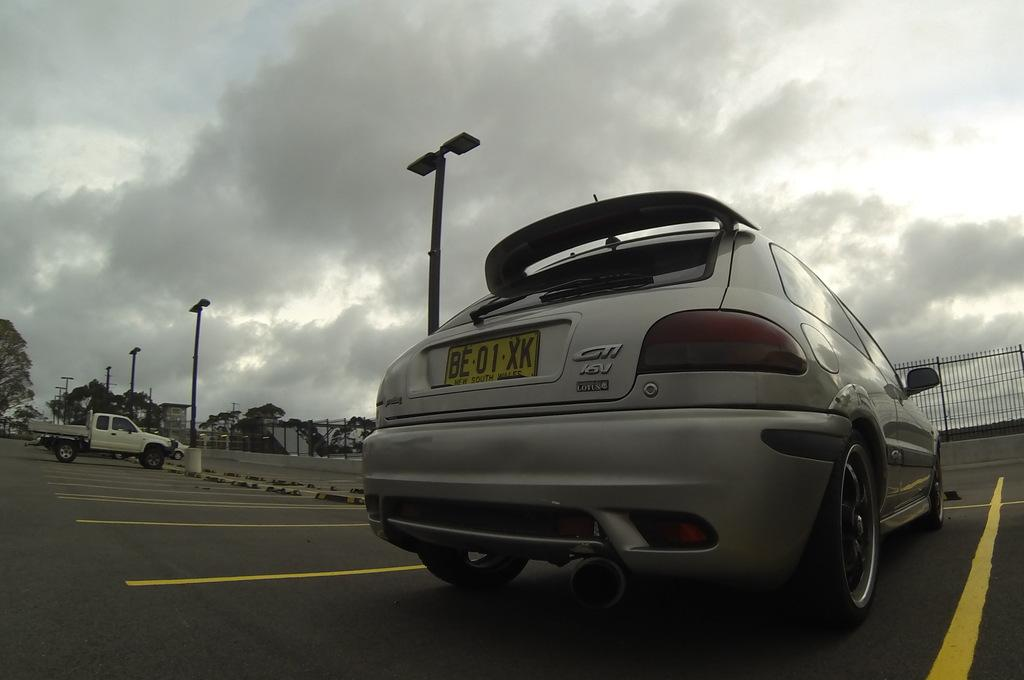What can be seen on the road in the image? There are vehicles on the road in the image. What type of markings are present on the road? The road has yellow lines. What structure is visible in the image? There is a light pole in the image. What type of natural elements are present in the image? Trees are present in the image. How would you describe the weather in the image? The sky is cloudy in the image. Can you identify any specific details on a vehicle in the image? There is a number plate visible on a vehicle. What shape is the glue used to hold the system together in the image? There is no system or glue present in the image; it features vehicles on a road with yellow lines, a light pole, trees, a cloudy sky, and a number plate on a vehicle. 